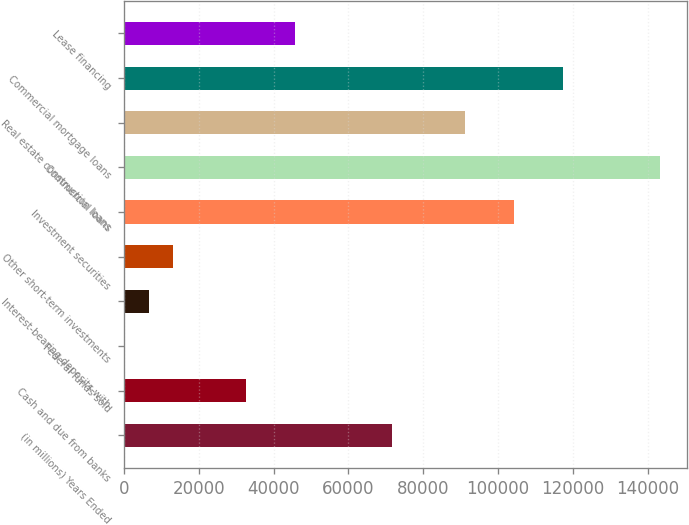Convert chart. <chart><loc_0><loc_0><loc_500><loc_500><bar_chart><fcel>(in millions) Years Ended<fcel>Cash and due from banks<fcel>Federal funds sold<fcel>Interest-bearing deposits with<fcel>Other short-term investments<fcel>Investment securities<fcel>Commercial loans<fcel>Real estate construction loans<fcel>Commercial mortgage loans<fcel>Lease financing<nl><fcel>71694.2<fcel>32639<fcel>93<fcel>6602.2<fcel>13111.4<fcel>104240<fcel>143295<fcel>91221.8<fcel>117259<fcel>45657.4<nl></chart> 